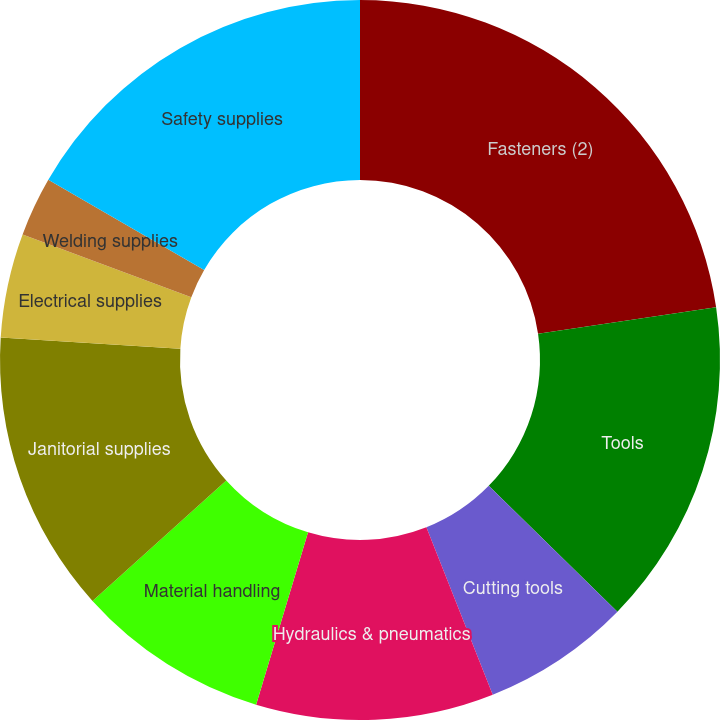Convert chart. <chart><loc_0><loc_0><loc_500><loc_500><pie_chart><fcel>Fasteners (2)<fcel>Tools<fcel>Cutting tools<fcel>Hydraulics & pneumatics<fcel>Material handling<fcel>Janitorial supplies<fcel>Electrical supplies<fcel>Welding supplies<fcel>Safety supplies<nl><fcel>22.66%<fcel>14.66%<fcel>6.67%<fcel>10.67%<fcel>8.67%<fcel>12.67%<fcel>4.67%<fcel>2.67%<fcel>16.66%<nl></chart> 